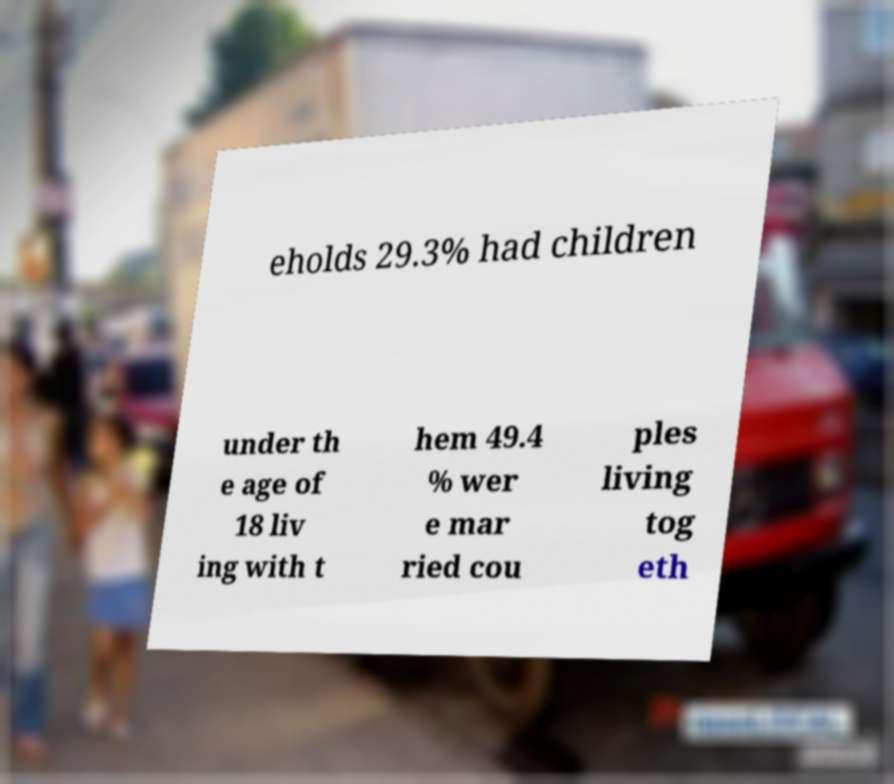There's text embedded in this image that I need extracted. Can you transcribe it verbatim? eholds 29.3% had children under th e age of 18 liv ing with t hem 49.4 % wer e mar ried cou ples living tog eth 